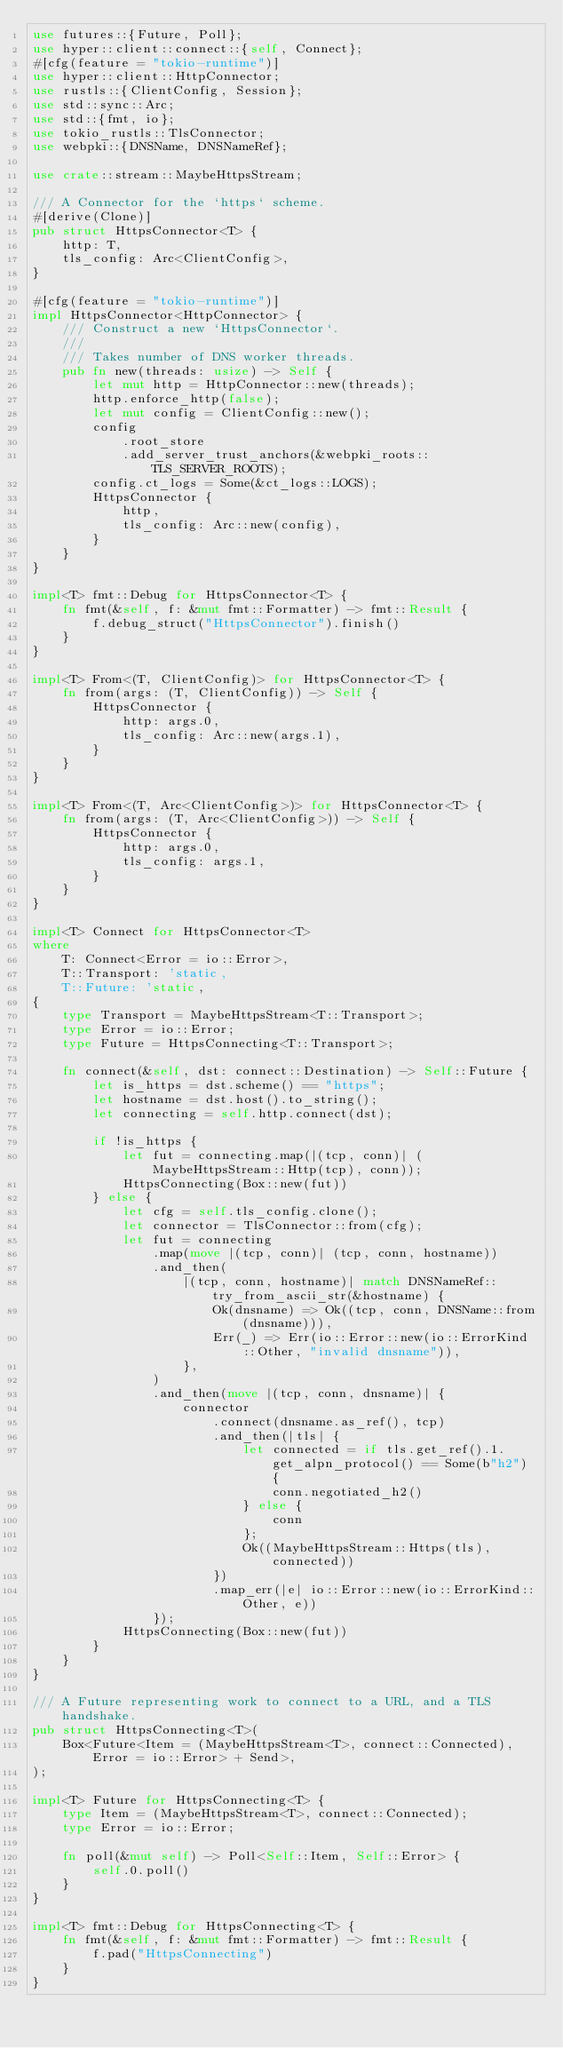<code> <loc_0><loc_0><loc_500><loc_500><_Rust_>use futures::{Future, Poll};
use hyper::client::connect::{self, Connect};
#[cfg(feature = "tokio-runtime")]
use hyper::client::HttpConnector;
use rustls::{ClientConfig, Session};
use std::sync::Arc;
use std::{fmt, io};
use tokio_rustls::TlsConnector;
use webpki::{DNSName, DNSNameRef};

use crate::stream::MaybeHttpsStream;

/// A Connector for the `https` scheme.
#[derive(Clone)]
pub struct HttpsConnector<T> {
    http: T,
    tls_config: Arc<ClientConfig>,
}

#[cfg(feature = "tokio-runtime")]
impl HttpsConnector<HttpConnector> {
    /// Construct a new `HttpsConnector`.
    ///
    /// Takes number of DNS worker threads.
    pub fn new(threads: usize) -> Self {
        let mut http = HttpConnector::new(threads);
        http.enforce_http(false);
        let mut config = ClientConfig::new();
        config
            .root_store
            .add_server_trust_anchors(&webpki_roots::TLS_SERVER_ROOTS);
        config.ct_logs = Some(&ct_logs::LOGS);
        HttpsConnector {
            http,
            tls_config: Arc::new(config),
        }
    }
}

impl<T> fmt::Debug for HttpsConnector<T> {
    fn fmt(&self, f: &mut fmt::Formatter) -> fmt::Result {
        f.debug_struct("HttpsConnector").finish()
    }
}

impl<T> From<(T, ClientConfig)> for HttpsConnector<T> {
    fn from(args: (T, ClientConfig)) -> Self {
        HttpsConnector {
            http: args.0,
            tls_config: Arc::new(args.1),
        }
    }
}

impl<T> From<(T, Arc<ClientConfig>)> for HttpsConnector<T> {
    fn from(args: (T, Arc<ClientConfig>)) -> Self {
        HttpsConnector {
            http: args.0,
            tls_config: args.1,
        }
    }
}

impl<T> Connect for HttpsConnector<T>
where
    T: Connect<Error = io::Error>,
    T::Transport: 'static,
    T::Future: 'static,
{
    type Transport = MaybeHttpsStream<T::Transport>;
    type Error = io::Error;
    type Future = HttpsConnecting<T::Transport>;

    fn connect(&self, dst: connect::Destination) -> Self::Future {
        let is_https = dst.scheme() == "https";
        let hostname = dst.host().to_string();
        let connecting = self.http.connect(dst);

        if !is_https {
            let fut = connecting.map(|(tcp, conn)| (MaybeHttpsStream::Http(tcp), conn));
            HttpsConnecting(Box::new(fut))
        } else {
            let cfg = self.tls_config.clone();
            let connector = TlsConnector::from(cfg);
            let fut = connecting
                .map(move |(tcp, conn)| (tcp, conn, hostname))
                .and_then(
                    |(tcp, conn, hostname)| match DNSNameRef::try_from_ascii_str(&hostname) {
                        Ok(dnsname) => Ok((tcp, conn, DNSName::from(dnsname))),
                        Err(_) => Err(io::Error::new(io::ErrorKind::Other, "invalid dnsname")),
                    },
                )
                .and_then(move |(tcp, conn, dnsname)| {
                    connector
                        .connect(dnsname.as_ref(), tcp)
                        .and_then(|tls| {
                            let connected = if tls.get_ref().1.get_alpn_protocol() == Some(b"h2") {
                                conn.negotiated_h2()
                            } else {
                                conn
                            };
                            Ok((MaybeHttpsStream::Https(tls), connected))
                        })
                        .map_err(|e| io::Error::new(io::ErrorKind::Other, e))
                });
            HttpsConnecting(Box::new(fut))
        }
    }
}

/// A Future representing work to connect to a URL, and a TLS handshake.
pub struct HttpsConnecting<T>(
    Box<Future<Item = (MaybeHttpsStream<T>, connect::Connected), Error = io::Error> + Send>,
);

impl<T> Future for HttpsConnecting<T> {
    type Item = (MaybeHttpsStream<T>, connect::Connected);
    type Error = io::Error;

    fn poll(&mut self) -> Poll<Self::Item, Self::Error> {
        self.0.poll()
    }
}

impl<T> fmt::Debug for HttpsConnecting<T> {
    fn fmt(&self, f: &mut fmt::Formatter) -> fmt::Result {
        f.pad("HttpsConnecting")
    }
}
</code> 